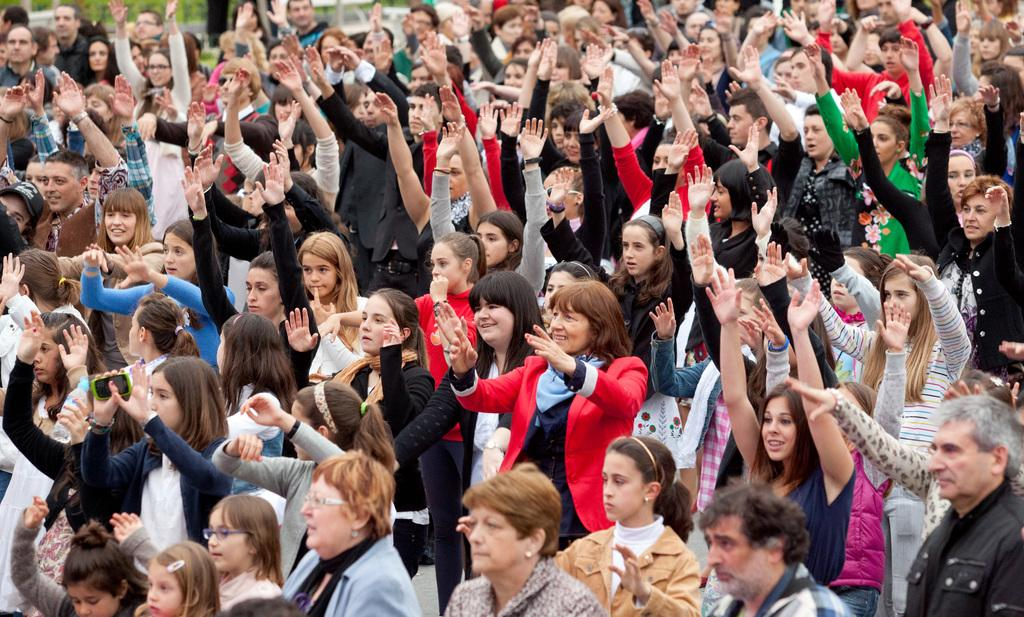What types of individuals are present in the image? There are women and men in the image. How are the people in the image feeling? The people in the image have cheerful faces, suggesting they are happy or excited. What are the people in the image doing with their hands? The people in the image are raising their hands. What type of bun is being held by the man in the image? There is no bun present in the image; the people are raising their hands, not holding any baked goods. 